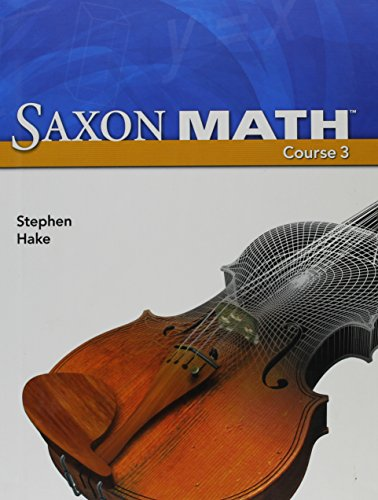Who wrote this book? The book 'Saxon Math Course 3' is published by SAXON PUBLISHERS, indicating the publisher on its cover, but the credited author is Stephen Hake. 